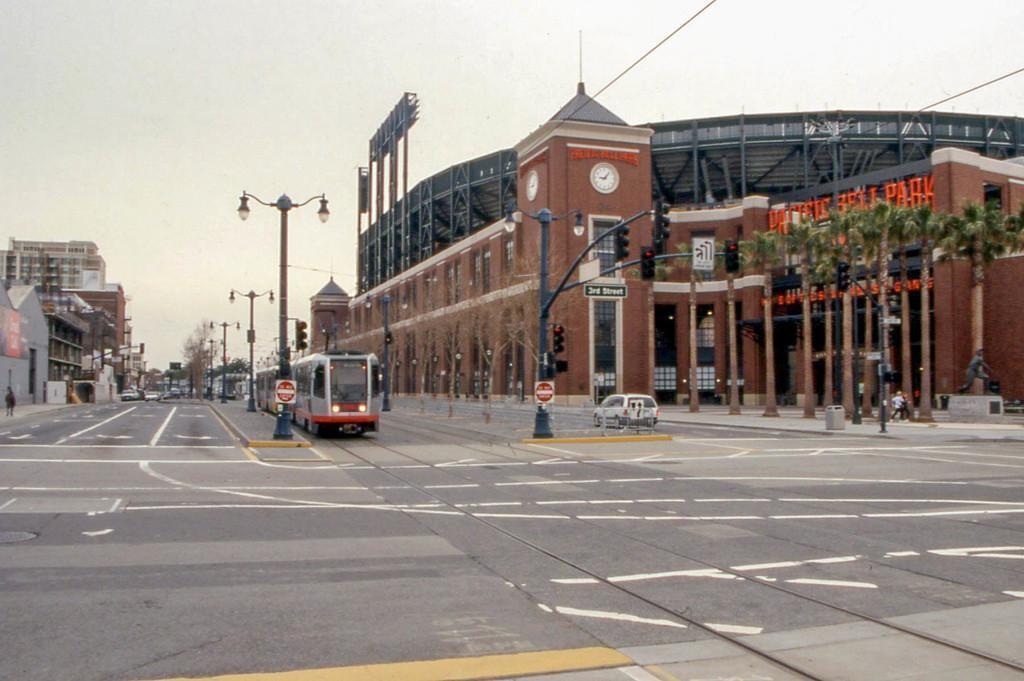Please provide a concise description of this image. This picture consists of building and a road and a vehicle and a traffic signal light ,street lights, trees at the top I can see the sky and I can see a clock attached to the wall of the building. 